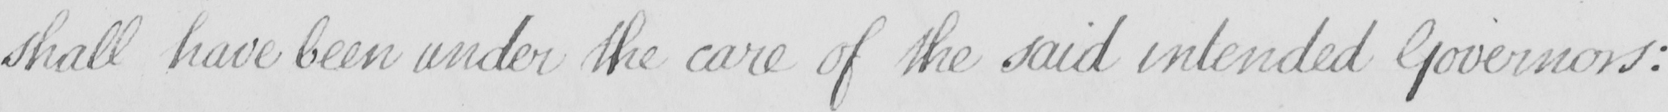Please provide the text content of this handwritten line. shall have been under the care of the said intended Governors : 